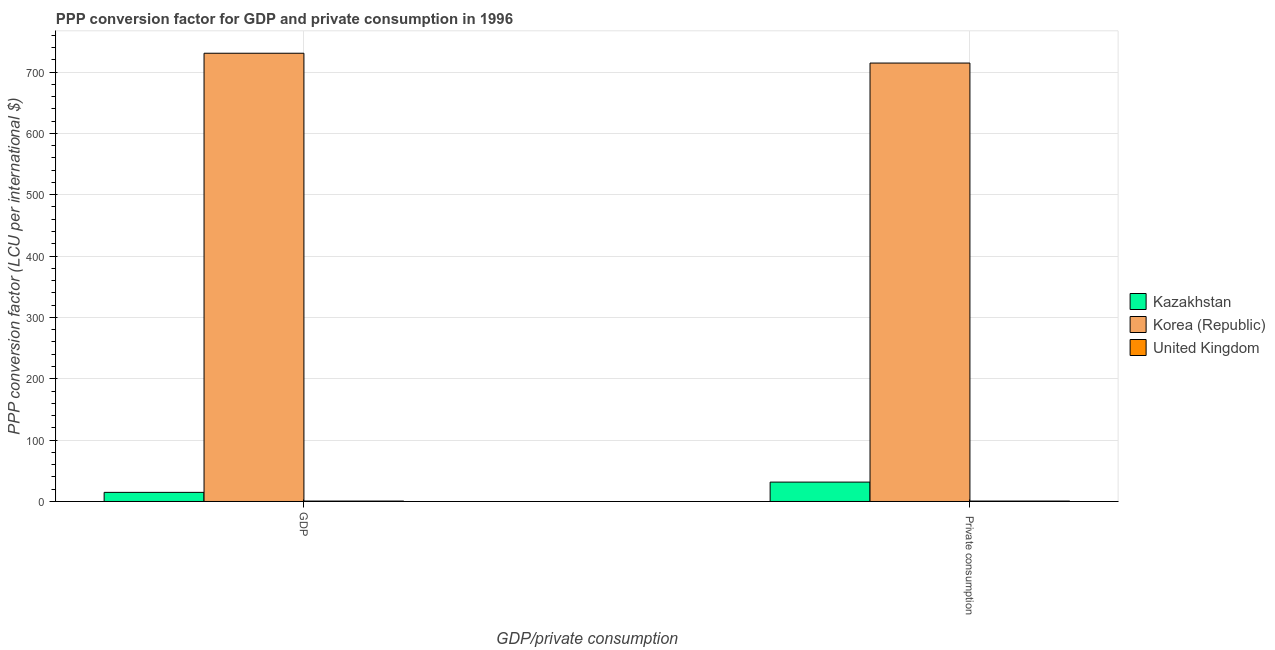How many different coloured bars are there?
Make the answer very short. 3. How many bars are there on the 2nd tick from the left?
Your answer should be compact. 3. What is the label of the 2nd group of bars from the left?
Give a very brief answer.  Private consumption. What is the ppp conversion factor for private consumption in Korea (Republic)?
Give a very brief answer. 714.59. Across all countries, what is the maximum ppp conversion factor for private consumption?
Make the answer very short. 714.59. Across all countries, what is the minimum ppp conversion factor for private consumption?
Your answer should be very brief. 0.66. In which country was the ppp conversion factor for private consumption minimum?
Your answer should be very brief. United Kingdom. What is the total ppp conversion factor for gdp in the graph?
Make the answer very short. 746.1. What is the difference between the ppp conversion factor for private consumption in Korea (Republic) and that in Kazakhstan?
Provide a short and direct response. 683.02. What is the difference between the ppp conversion factor for private consumption in Kazakhstan and the ppp conversion factor for gdp in Korea (Republic)?
Your answer should be compact. -699.03. What is the average ppp conversion factor for private consumption per country?
Give a very brief answer. 248.94. What is the difference between the ppp conversion factor for gdp and ppp conversion factor for private consumption in Korea (Republic)?
Keep it short and to the point. 16.01. In how many countries, is the ppp conversion factor for gdp greater than 740 LCU?
Offer a very short reply. 0. What is the ratio of the ppp conversion factor for private consumption in Korea (Republic) to that in United Kingdom?
Your response must be concise. 1087.76. Is the ppp conversion factor for gdp in Korea (Republic) less than that in United Kingdom?
Your answer should be compact. No. What does the 3rd bar from the right in  Private consumption represents?
Offer a terse response. Kazakhstan. Are all the bars in the graph horizontal?
Provide a succinct answer. No. How many countries are there in the graph?
Offer a terse response. 3. What is the difference between two consecutive major ticks on the Y-axis?
Your response must be concise. 100. Are the values on the major ticks of Y-axis written in scientific E-notation?
Ensure brevity in your answer.  No. Does the graph contain any zero values?
Ensure brevity in your answer.  No. Where does the legend appear in the graph?
Your answer should be very brief. Center right. How many legend labels are there?
Offer a terse response. 3. How are the legend labels stacked?
Provide a short and direct response. Vertical. What is the title of the graph?
Provide a short and direct response. PPP conversion factor for GDP and private consumption in 1996. What is the label or title of the X-axis?
Offer a terse response. GDP/private consumption. What is the label or title of the Y-axis?
Give a very brief answer. PPP conversion factor (LCU per international $). What is the PPP conversion factor (LCU per international $) in Kazakhstan in GDP?
Provide a succinct answer. 14.85. What is the PPP conversion factor (LCU per international $) of Korea (Republic) in GDP?
Your answer should be very brief. 730.61. What is the PPP conversion factor (LCU per international $) in United Kingdom in GDP?
Provide a short and direct response. 0.64. What is the PPP conversion factor (LCU per international $) in Kazakhstan in  Private consumption?
Provide a succinct answer. 31.57. What is the PPP conversion factor (LCU per international $) of Korea (Republic) in  Private consumption?
Make the answer very short. 714.59. What is the PPP conversion factor (LCU per international $) of United Kingdom in  Private consumption?
Keep it short and to the point. 0.66. Across all GDP/private consumption, what is the maximum PPP conversion factor (LCU per international $) of Kazakhstan?
Keep it short and to the point. 31.57. Across all GDP/private consumption, what is the maximum PPP conversion factor (LCU per international $) of Korea (Republic)?
Provide a short and direct response. 730.61. Across all GDP/private consumption, what is the maximum PPP conversion factor (LCU per international $) in United Kingdom?
Provide a succinct answer. 0.66. Across all GDP/private consumption, what is the minimum PPP conversion factor (LCU per international $) in Kazakhstan?
Your answer should be compact. 14.85. Across all GDP/private consumption, what is the minimum PPP conversion factor (LCU per international $) of Korea (Republic)?
Your response must be concise. 714.59. Across all GDP/private consumption, what is the minimum PPP conversion factor (LCU per international $) in United Kingdom?
Your answer should be very brief. 0.64. What is the total PPP conversion factor (LCU per international $) of Kazakhstan in the graph?
Offer a terse response. 46.42. What is the total PPP conversion factor (LCU per international $) of Korea (Republic) in the graph?
Offer a very short reply. 1445.2. What is the total PPP conversion factor (LCU per international $) in United Kingdom in the graph?
Offer a very short reply. 1.3. What is the difference between the PPP conversion factor (LCU per international $) of Kazakhstan in GDP and that in  Private consumption?
Your response must be concise. -16.72. What is the difference between the PPP conversion factor (LCU per international $) of Korea (Republic) in GDP and that in  Private consumption?
Ensure brevity in your answer.  16.01. What is the difference between the PPP conversion factor (LCU per international $) of United Kingdom in GDP and that in  Private consumption?
Make the answer very short. -0.02. What is the difference between the PPP conversion factor (LCU per international $) in Kazakhstan in GDP and the PPP conversion factor (LCU per international $) in Korea (Republic) in  Private consumption?
Give a very brief answer. -699.74. What is the difference between the PPP conversion factor (LCU per international $) of Kazakhstan in GDP and the PPP conversion factor (LCU per international $) of United Kingdom in  Private consumption?
Your response must be concise. 14.19. What is the difference between the PPP conversion factor (LCU per international $) of Korea (Republic) in GDP and the PPP conversion factor (LCU per international $) of United Kingdom in  Private consumption?
Your answer should be compact. 729.95. What is the average PPP conversion factor (LCU per international $) of Kazakhstan per GDP/private consumption?
Ensure brevity in your answer.  23.21. What is the average PPP conversion factor (LCU per international $) of Korea (Republic) per GDP/private consumption?
Provide a short and direct response. 722.6. What is the average PPP conversion factor (LCU per international $) in United Kingdom per GDP/private consumption?
Offer a terse response. 0.65. What is the difference between the PPP conversion factor (LCU per international $) of Kazakhstan and PPP conversion factor (LCU per international $) of Korea (Republic) in GDP?
Keep it short and to the point. -715.76. What is the difference between the PPP conversion factor (LCU per international $) in Kazakhstan and PPP conversion factor (LCU per international $) in United Kingdom in GDP?
Your answer should be very brief. 14.21. What is the difference between the PPP conversion factor (LCU per international $) in Korea (Republic) and PPP conversion factor (LCU per international $) in United Kingdom in GDP?
Your response must be concise. 729.97. What is the difference between the PPP conversion factor (LCU per international $) in Kazakhstan and PPP conversion factor (LCU per international $) in Korea (Republic) in  Private consumption?
Offer a terse response. -683.02. What is the difference between the PPP conversion factor (LCU per international $) of Kazakhstan and PPP conversion factor (LCU per international $) of United Kingdom in  Private consumption?
Provide a succinct answer. 30.92. What is the difference between the PPP conversion factor (LCU per international $) in Korea (Republic) and PPP conversion factor (LCU per international $) in United Kingdom in  Private consumption?
Make the answer very short. 713.93. What is the ratio of the PPP conversion factor (LCU per international $) in Kazakhstan in GDP to that in  Private consumption?
Keep it short and to the point. 0.47. What is the ratio of the PPP conversion factor (LCU per international $) of Korea (Republic) in GDP to that in  Private consumption?
Make the answer very short. 1.02. What is the ratio of the PPP conversion factor (LCU per international $) of United Kingdom in GDP to that in  Private consumption?
Provide a succinct answer. 0.98. What is the difference between the highest and the second highest PPP conversion factor (LCU per international $) in Kazakhstan?
Provide a succinct answer. 16.72. What is the difference between the highest and the second highest PPP conversion factor (LCU per international $) of Korea (Republic)?
Offer a terse response. 16.01. What is the difference between the highest and the second highest PPP conversion factor (LCU per international $) of United Kingdom?
Offer a terse response. 0.02. What is the difference between the highest and the lowest PPP conversion factor (LCU per international $) in Kazakhstan?
Ensure brevity in your answer.  16.72. What is the difference between the highest and the lowest PPP conversion factor (LCU per international $) of Korea (Republic)?
Give a very brief answer. 16.01. What is the difference between the highest and the lowest PPP conversion factor (LCU per international $) of United Kingdom?
Your answer should be very brief. 0.02. 